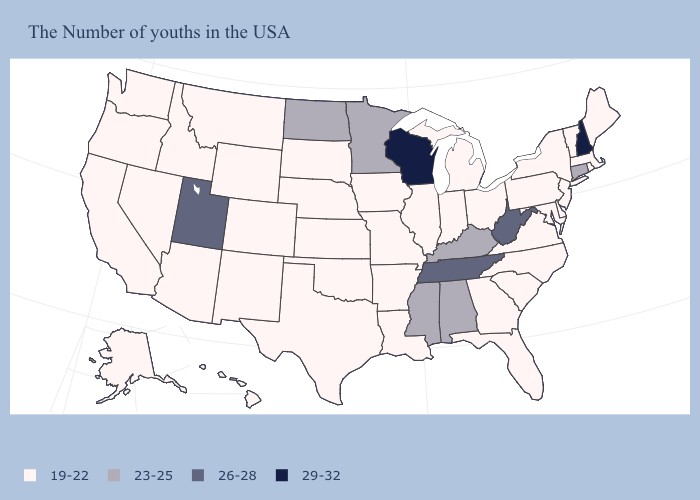Does Ohio have a higher value than California?
Quick response, please. No. Does the map have missing data?
Write a very short answer. No. Name the states that have a value in the range 19-22?
Short answer required. Maine, Massachusetts, Rhode Island, Vermont, New York, New Jersey, Delaware, Maryland, Pennsylvania, Virginia, North Carolina, South Carolina, Ohio, Florida, Georgia, Michigan, Indiana, Illinois, Louisiana, Missouri, Arkansas, Iowa, Kansas, Nebraska, Oklahoma, Texas, South Dakota, Wyoming, Colorado, New Mexico, Montana, Arizona, Idaho, Nevada, California, Washington, Oregon, Alaska, Hawaii. How many symbols are there in the legend?
Quick response, please. 4. Name the states that have a value in the range 29-32?
Short answer required. New Hampshire, Wisconsin. Among the states that border Delaware , which have the highest value?
Concise answer only. New Jersey, Maryland, Pennsylvania. Which states have the lowest value in the USA?
Write a very short answer. Maine, Massachusetts, Rhode Island, Vermont, New York, New Jersey, Delaware, Maryland, Pennsylvania, Virginia, North Carolina, South Carolina, Ohio, Florida, Georgia, Michigan, Indiana, Illinois, Louisiana, Missouri, Arkansas, Iowa, Kansas, Nebraska, Oklahoma, Texas, South Dakota, Wyoming, Colorado, New Mexico, Montana, Arizona, Idaho, Nevada, California, Washington, Oregon, Alaska, Hawaii. Does Pennsylvania have the highest value in the Northeast?
Be succinct. No. What is the value of Iowa?
Concise answer only. 19-22. What is the value of Georgia?
Write a very short answer. 19-22. What is the highest value in states that border New York?
Short answer required. 23-25. Among the states that border North Carolina , does Tennessee have the lowest value?
Write a very short answer. No. Does Wyoming have the highest value in the USA?
Answer briefly. No. Is the legend a continuous bar?
Be succinct. No. Does Wisconsin have the highest value in the MidWest?
Quick response, please. Yes. 